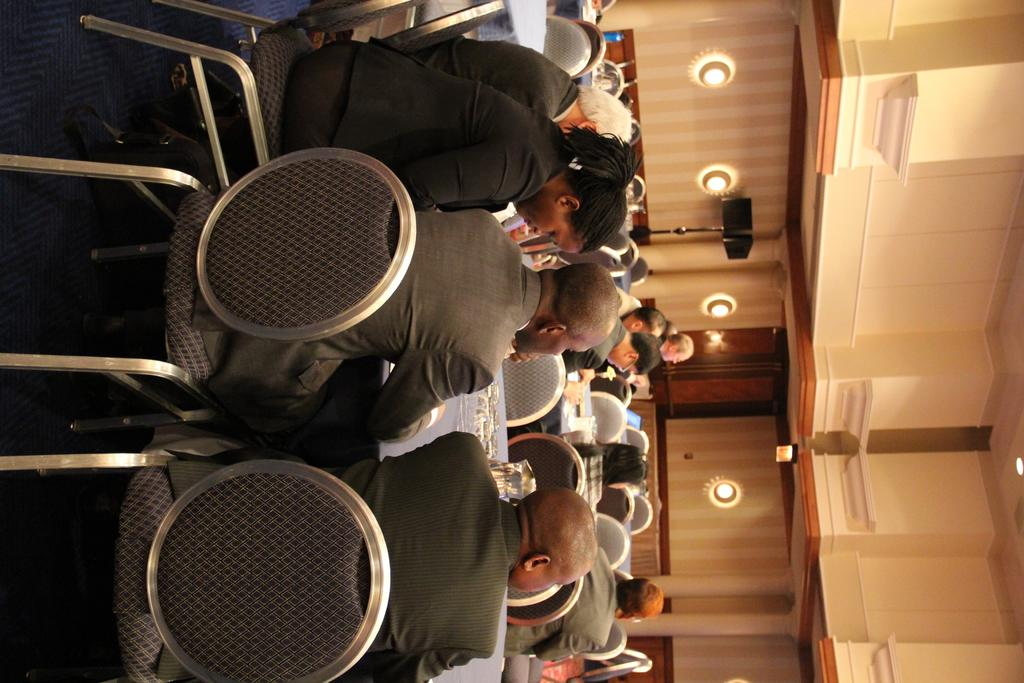How many people are in the image? There is a group of people in the image. What are the people doing in the image? The people are sitting around different tables. What can be seen in the background of the image? There is a wooden wall in the background of the image. What is in front of the wooden wall? There is an object in front of the wooden wall. What type of chain can be seen hanging from the ceiling in the image? There is no chain visible in the image; it only features a group of people, tables, a wooden wall, and an object in front of the wall. 